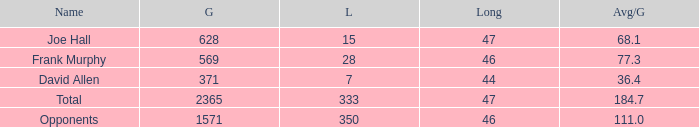How much Loss has a Gain smaller than 1571, and a Long smaller than 47, and an Avg/G of 36.4? 1.0. 